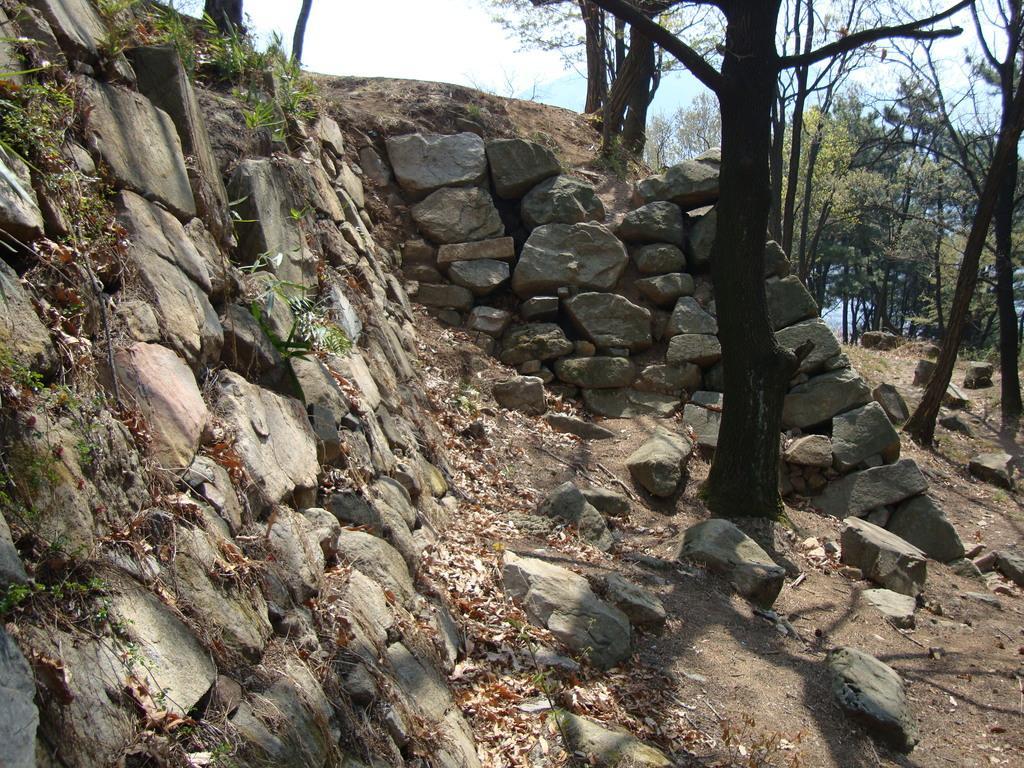In one or two sentences, can you explain what this image depicts? In this image we can see some stones, grass, dry leaves and trees, in the background we can see the sky. 